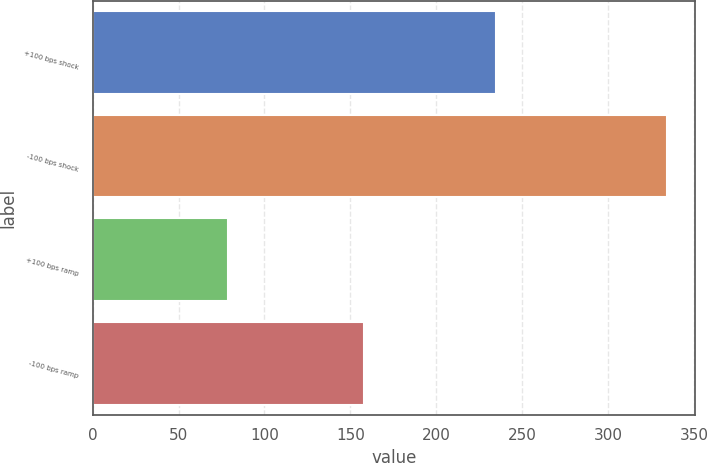Convert chart. <chart><loc_0><loc_0><loc_500><loc_500><bar_chart><fcel>+100 bps shock<fcel>-100 bps shock<fcel>+100 bps ramp<fcel>-100 bps ramp<nl><fcel>235<fcel>334<fcel>79<fcel>158<nl></chart> 